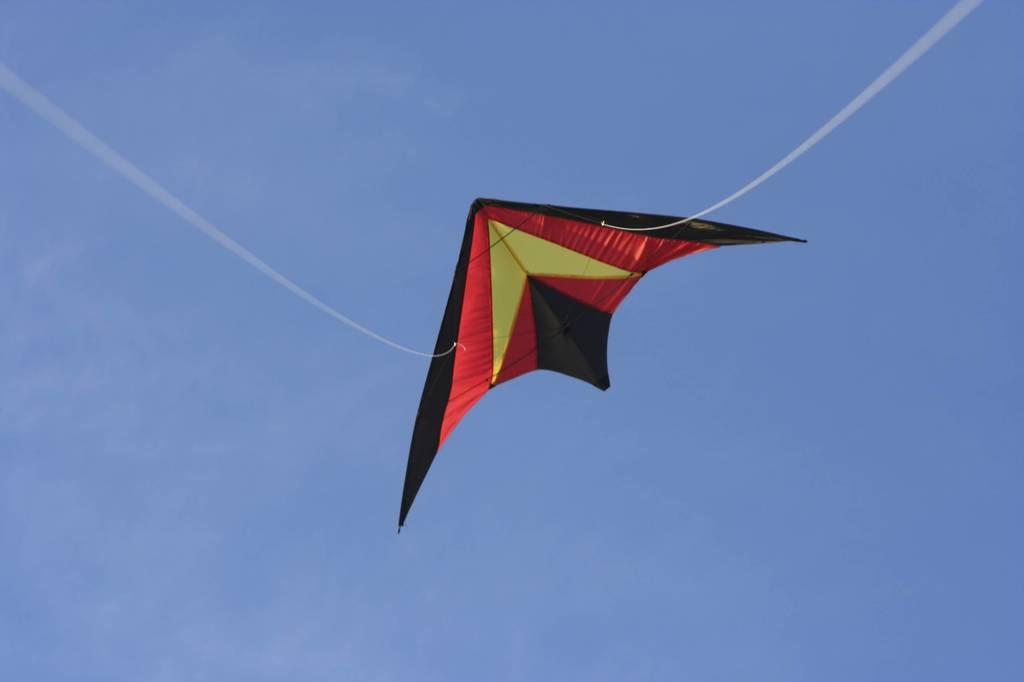What is the main subject of the image? The main subject of the image is a kite. What colors can be seen on the kite? The kite has black, red, and yellow colors. How is the kite being used in the image? The kite is flying with threads. What can be seen in the background of the image? There is sky visible in the background of the image. What type of song is being played in the background of the image? There is no song playing in the background of the image; it only features a kite flying with threads against a sky backdrop. 